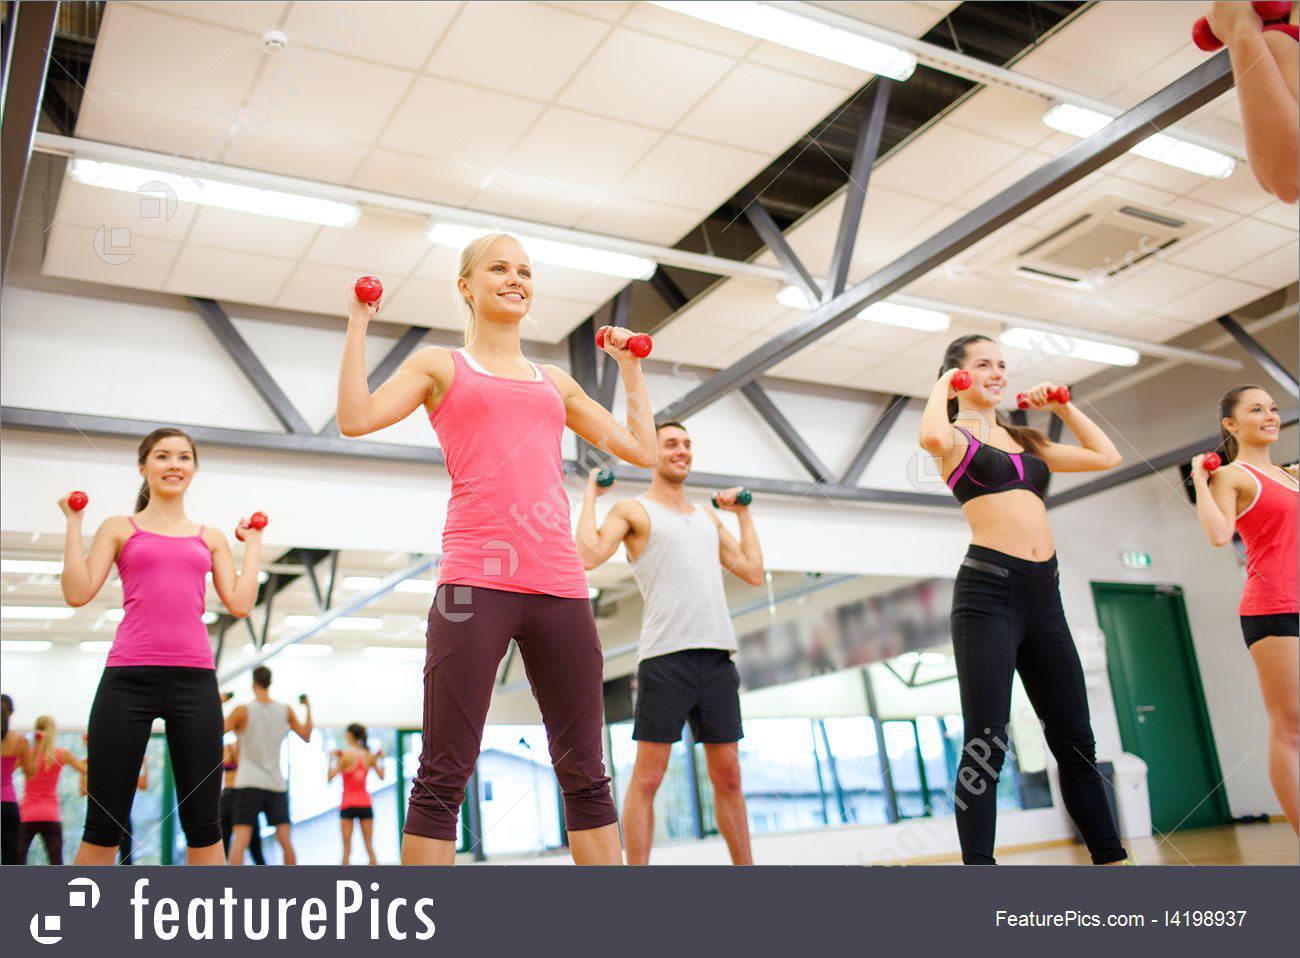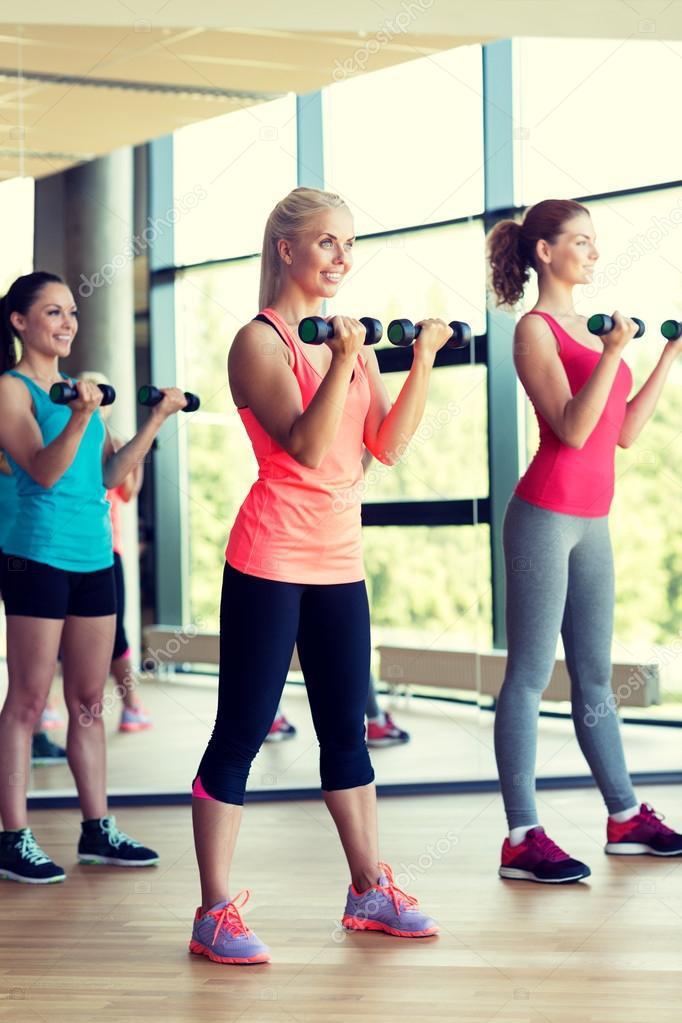The first image is the image on the left, the second image is the image on the right. For the images shown, is this caption "One image shows a workout with feet flat on the floor and hands holding dumbbells in front of the body, and the other image shows a similar workout with hands holding dumbbells out to the side." true? Answer yes or no. Yes. The first image is the image on the left, the second image is the image on the right. Assess this claim about the two images: "At least five women are stepping on a workout step with one foot.". Correct or not? Answer yes or no. No. 